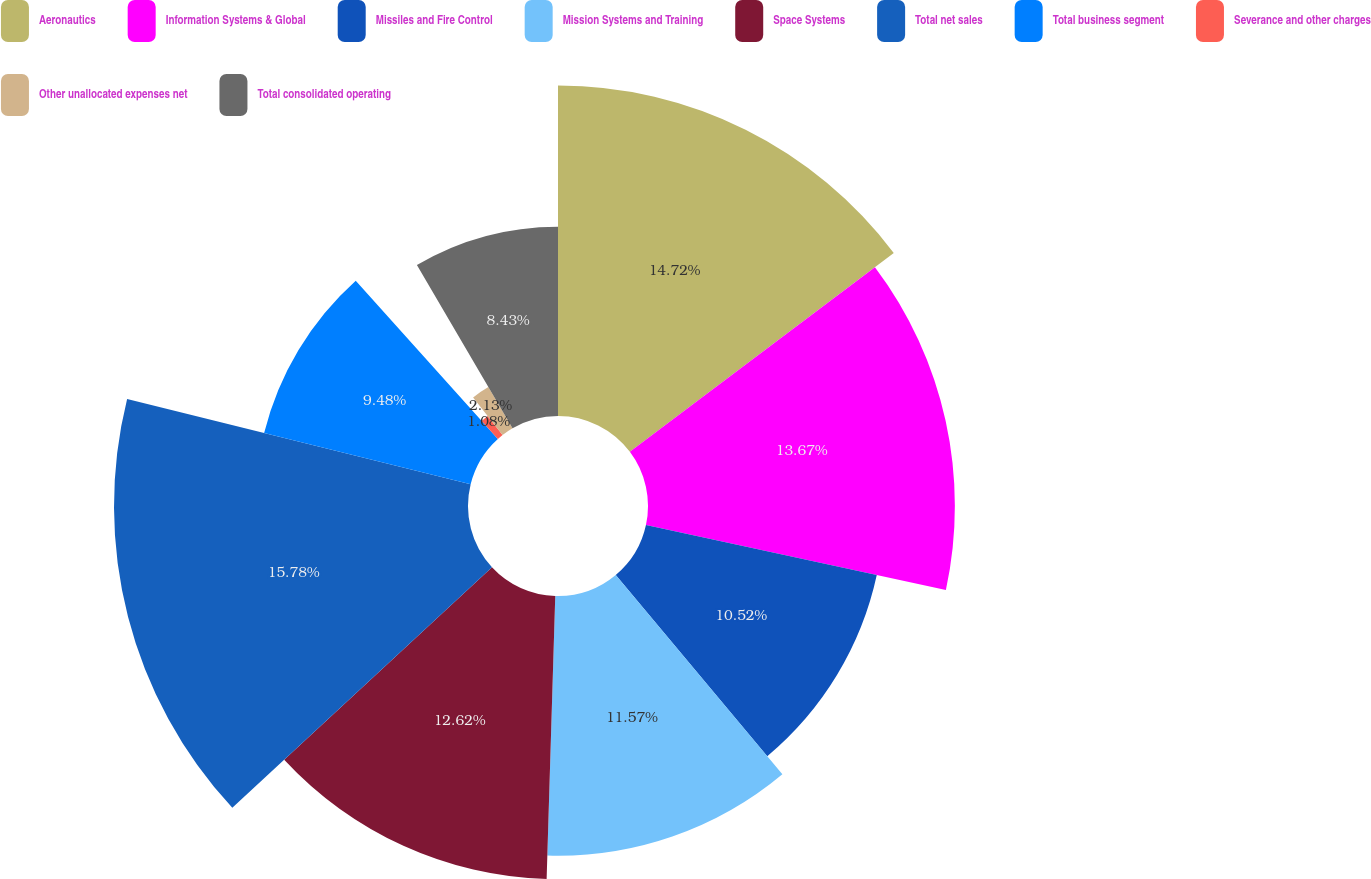<chart> <loc_0><loc_0><loc_500><loc_500><pie_chart><fcel>Aeronautics<fcel>Information Systems & Global<fcel>Missiles and Fire Control<fcel>Mission Systems and Training<fcel>Space Systems<fcel>Total net sales<fcel>Total business segment<fcel>Severance and other charges<fcel>Other unallocated expenses net<fcel>Total consolidated operating<nl><fcel>14.72%<fcel>13.67%<fcel>10.52%<fcel>11.57%<fcel>12.62%<fcel>15.77%<fcel>9.48%<fcel>1.08%<fcel>2.13%<fcel>8.43%<nl></chart> 